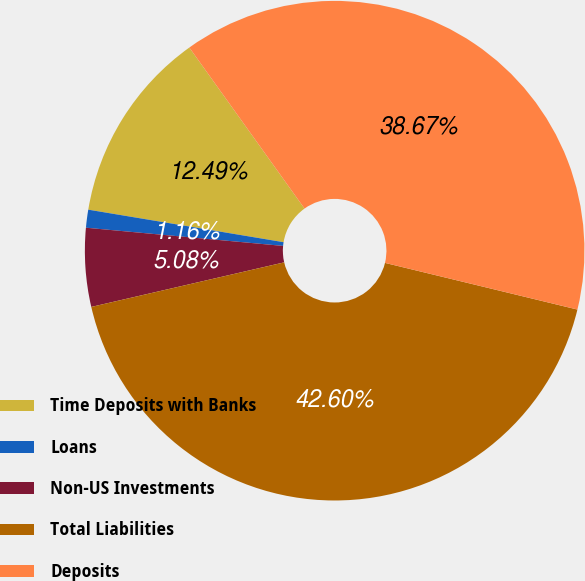Convert chart to OTSL. <chart><loc_0><loc_0><loc_500><loc_500><pie_chart><fcel>Time Deposits with Banks<fcel>Loans<fcel>Non-US Investments<fcel>Total Liabilities<fcel>Deposits<nl><fcel>12.49%<fcel>1.16%<fcel>5.08%<fcel>42.6%<fcel>38.67%<nl></chart> 